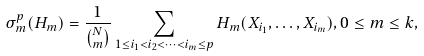<formula> <loc_0><loc_0><loc_500><loc_500>\sigma _ { m } ^ { p } ( H _ { m } ) = \frac { 1 } { \binom { N } { m } } \sum _ { 1 \leq i _ { 1 } < i _ { 2 } < \dots < i _ { m } \leq p } H _ { m } ( X _ { i _ { 1 } } , \dots , X _ { i _ { m } } ) , 0 \leq m \leq k ,</formula> 